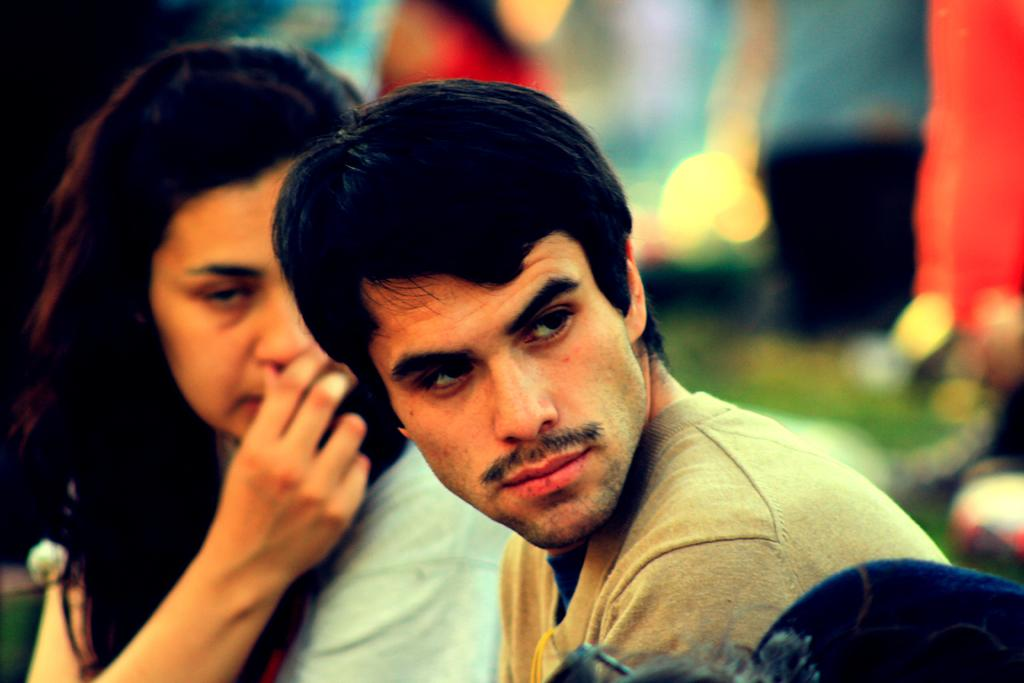Who are the people in the image? There is a man and a woman in the image. Are there any other people in the image besides the man and woman? No, there are no other people mentioned in the provided facts. What color is the pet in the image? There is no pet present in the image. What type of surprise is the woman holding in the image? There is no surprise visible in the image. Is the man painting a picture in the image? The provided facts do not mention anything about the man painting a picture. 